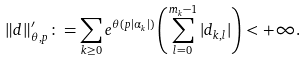Convert formula to latex. <formula><loc_0><loc_0><loc_500><loc_500>\| d \| ^ { \prime } _ { \theta , p } \colon = \sum _ { k \geq 0 } e ^ { { \theta } ( p | \alpha _ { k } | ) } \left ( \sum _ { l = 0 } ^ { m _ { k } - 1 } | d _ { k , l } | \right ) < + \infty .</formula> 